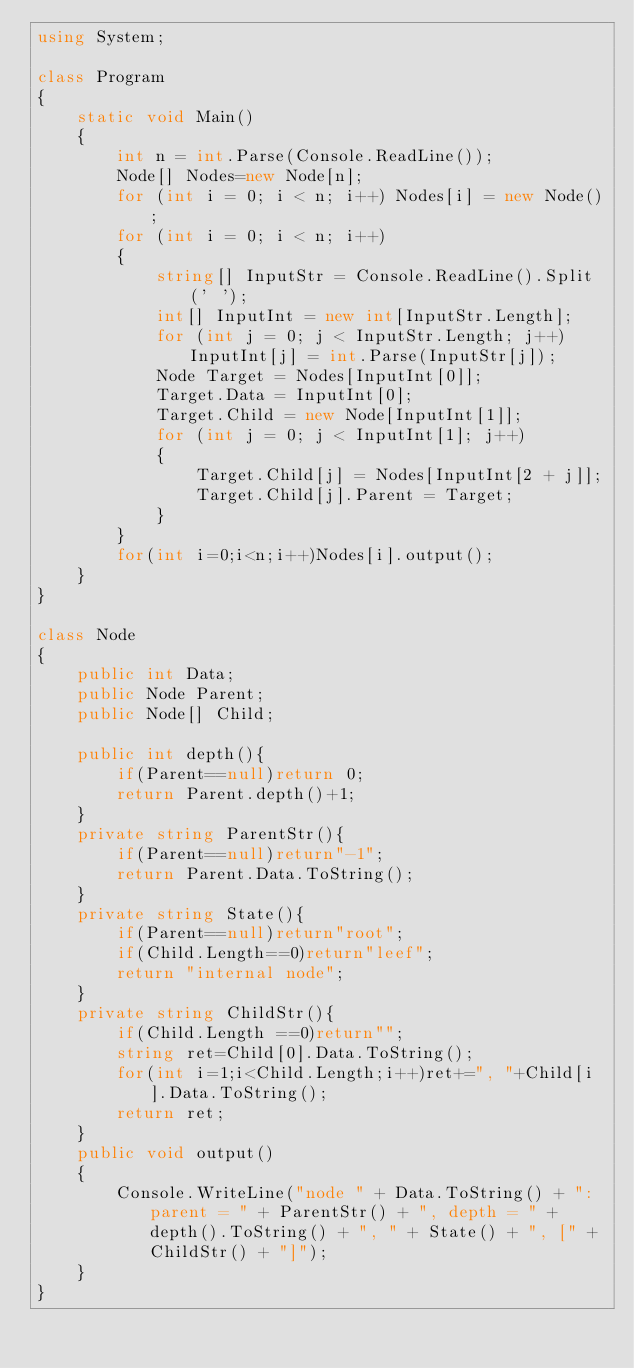Convert code to text. <code><loc_0><loc_0><loc_500><loc_500><_C#_>using System;

class Program
{
    static void Main()
    {
        int n = int.Parse(Console.ReadLine());
        Node[] Nodes=new Node[n];
        for (int i = 0; i < n; i++) Nodes[i] = new Node();
        for (int i = 0; i < n; i++)
        {
            string[] InputStr = Console.ReadLine().Split(' ');
            int[] InputInt = new int[InputStr.Length];
            for (int j = 0; j < InputStr.Length; j++) InputInt[j] = int.Parse(InputStr[j]);
            Node Target = Nodes[InputInt[0]];
            Target.Data = InputInt[0];
            Target.Child = new Node[InputInt[1]];
            for (int j = 0; j < InputInt[1]; j++)
            {
                Target.Child[j] = Nodes[InputInt[2 + j]];
                Target.Child[j].Parent = Target;
            }
        }
        for(int i=0;i<n;i++)Nodes[i].output();
    }
}

class Node
{
    public int Data;
    public Node Parent;
    public Node[] Child;

    public int depth(){
        if(Parent==null)return 0;
        return Parent.depth()+1;
    }
    private string ParentStr(){
        if(Parent==null)return"-1";
        return Parent.Data.ToString();
    }
    private string State(){
        if(Parent==null)return"root";
        if(Child.Length==0)return"leef";
        return "internal node";
    }
    private string ChildStr(){
        if(Child.Length ==0)return"";
        string ret=Child[0].Data.ToString();
        for(int i=1;i<Child.Length;i++)ret+=", "+Child[i].Data.ToString();
        return ret;
    }
    public void output()
    {
        Console.WriteLine("node " + Data.ToString() + ": parent = " + ParentStr() + ", depth = " + depth().ToString() + ", " + State() + ", [" + ChildStr() + "]");
    }
}</code> 